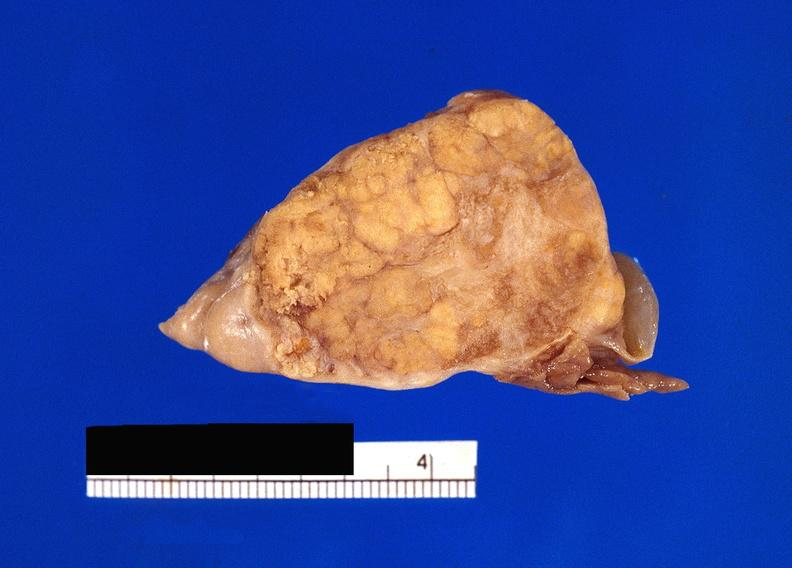does this image show pancreatic fat necrosis?
Answer the question using a single word or phrase. Yes 